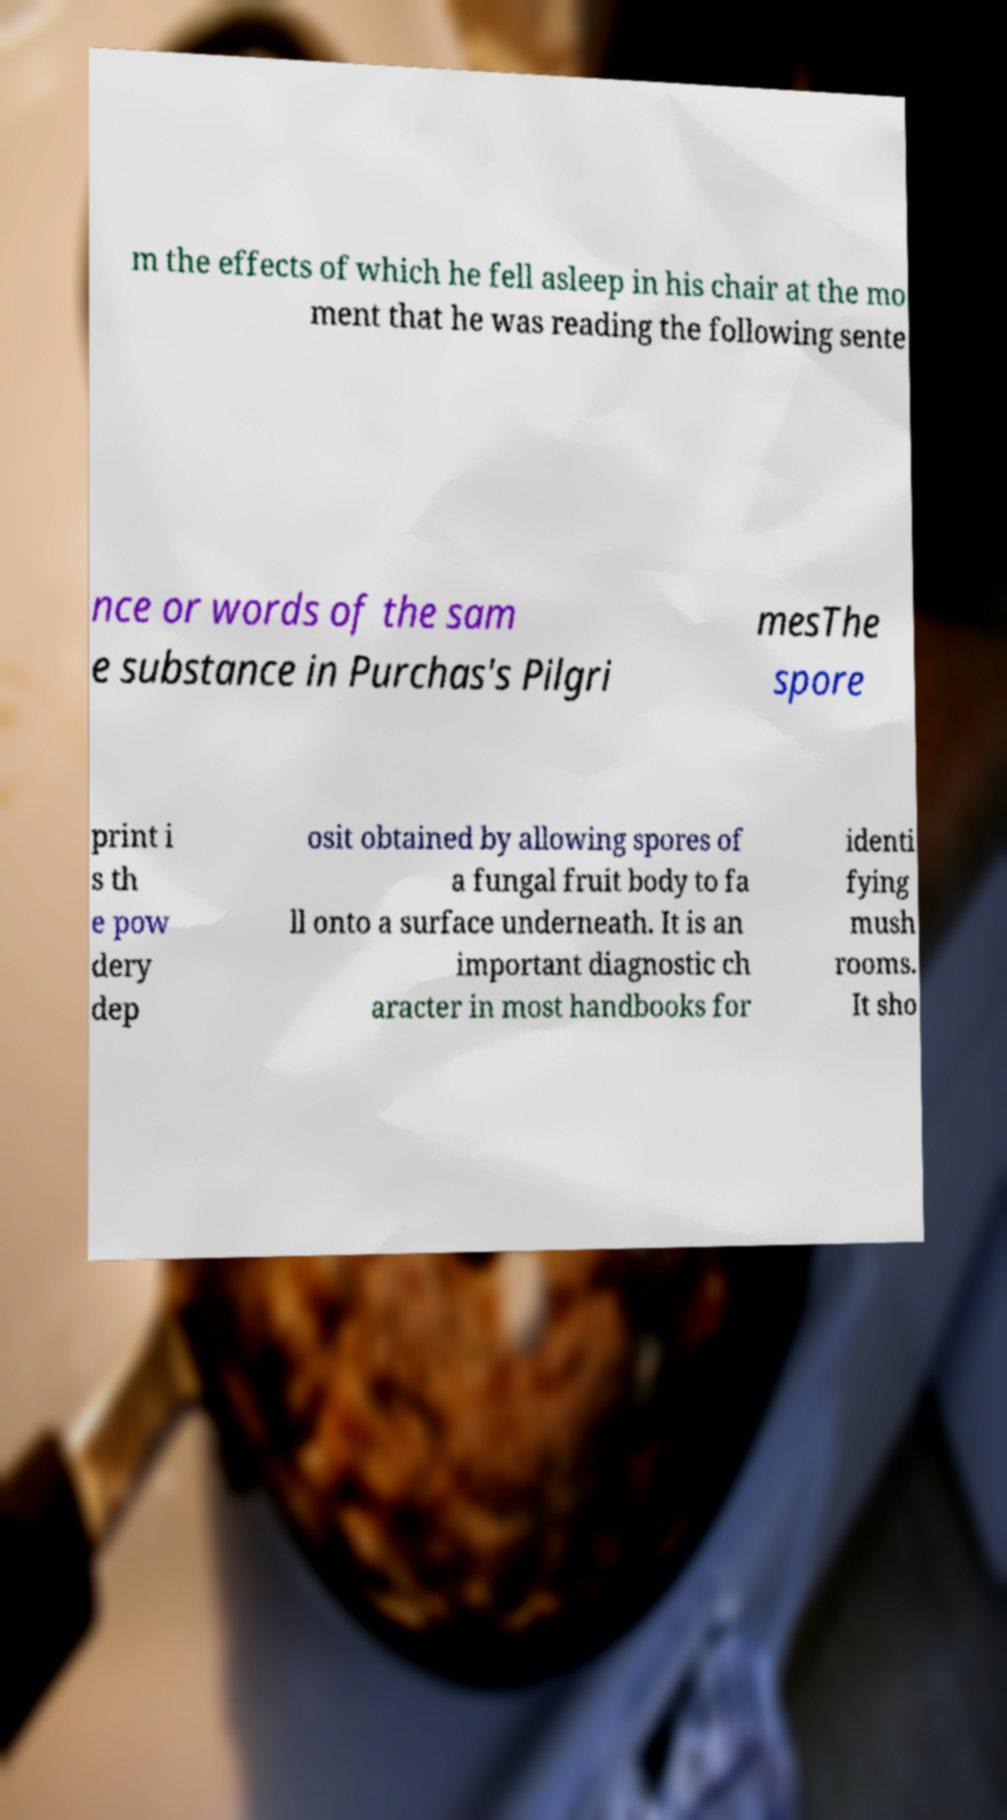Could you extract and type out the text from this image? m the effects of which he fell asleep in his chair at the mo ment that he was reading the following sente nce or words of the sam e substance in Purchas's Pilgri mesThe spore print i s th e pow dery dep osit obtained by allowing spores of a fungal fruit body to fa ll onto a surface underneath. It is an important diagnostic ch aracter in most handbooks for identi fying mush rooms. It sho 